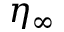<formula> <loc_0><loc_0><loc_500><loc_500>\eta _ { \infty }</formula> 